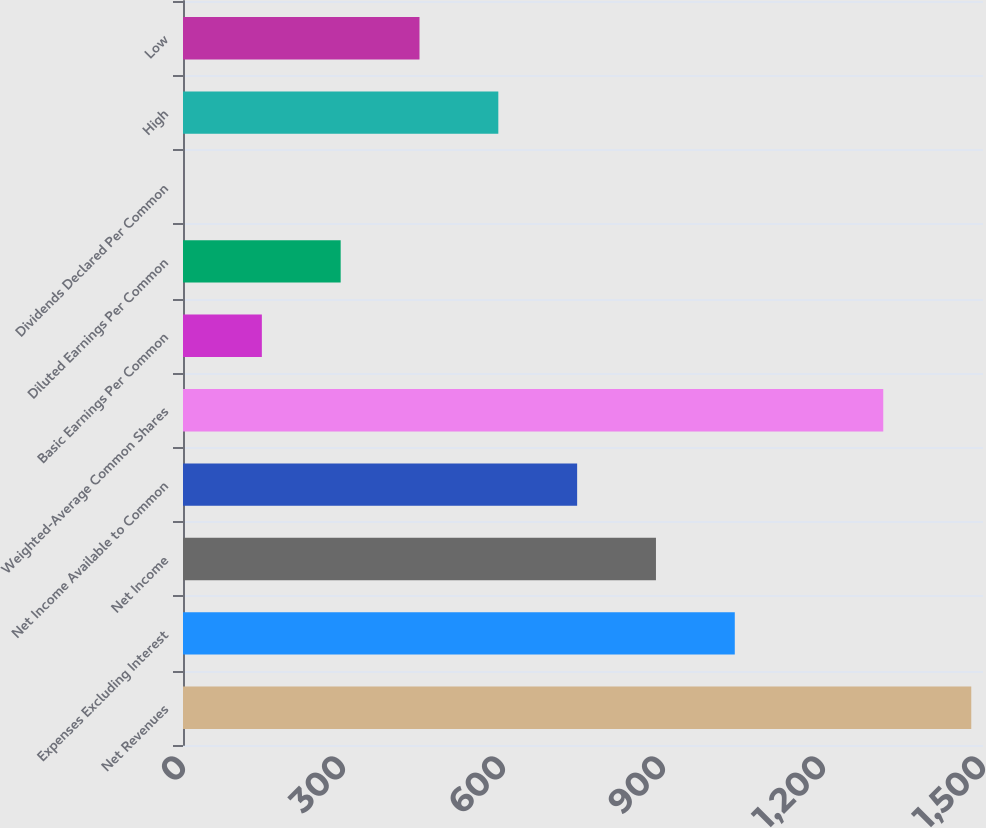Convert chart. <chart><loc_0><loc_0><loc_500><loc_500><bar_chart><fcel>Net Revenues<fcel>Expenses Excluding Interest<fcel>Net Income<fcel>Net Income Available to Common<fcel>Weighted-Average Common Shares<fcel>Basic Earnings Per Common<fcel>Diluted Earnings Per Common<fcel>Dividends Declared Per Common<fcel>High<fcel>Low<nl><fcel>1478<fcel>1034.59<fcel>886.8<fcel>739.01<fcel>1313<fcel>147.85<fcel>295.64<fcel>0.06<fcel>591.22<fcel>443.43<nl></chart> 